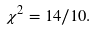<formula> <loc_0><loc_0><loc_500><loc_500>\chi ^ { 2 } = 1 4 / 1 0 .</formula> 